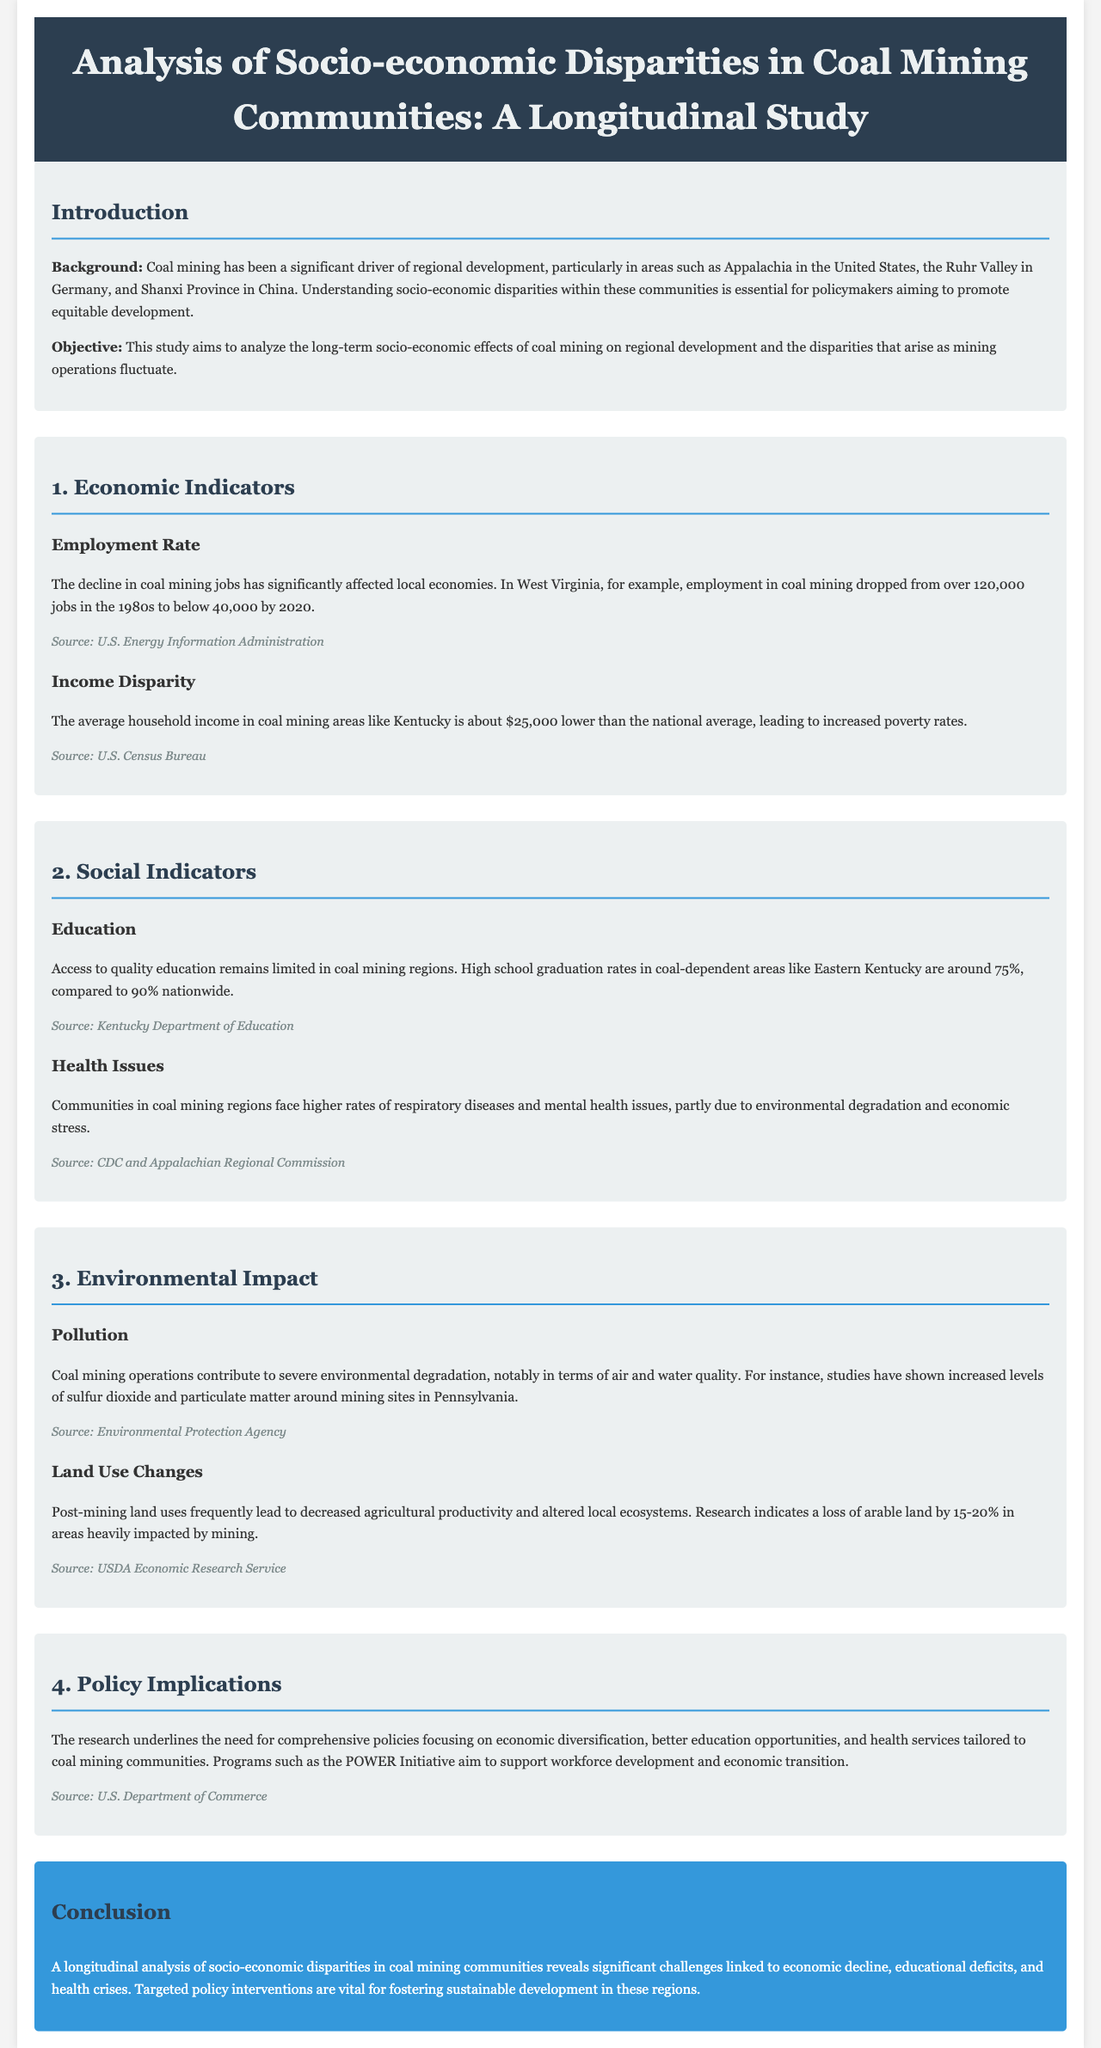what was the employment rate in West Virginia in the 1980s? The employment in coal mining in West Virginia was over 120,000 jobs in the 1980s.
Answer: over 120,000 jobs how much lower is the average household income in coal mining areas like Kentucky compared to the national average? The average household income in coal mining areas like Kentucky is about $25,000 lower than the national average.
Answer: $25,000 lower what is the high school graduation rate in Eastern Kentucky? The high school graduation rate in coal-dependent areas like Eastern Kentucky is around 75%.
Answer: around 75% what percentage of arable land has been lost in areas heavily impacted by mining? Research indicates a loss of arable land by 15-20% in areas heavily impacted by mining.
Answer: 15-20% which initiative aims to support workforce development and economic transition? Programs such as the POWER Initiative aim to support workforce development and economic transition.
Answer: POWER Initiative what are some health issues faced by coal mining communities? Communities in coal mining regions face higher rates of respiratory diseases and mental health issues.
Answer: respiratory diseases and mental health issues what is a significant background factor influencing coal mining communities? Coal mining has been a significant driver of regional development.
Answer: regional development why is understanding socio-economic disparities in coal mining communities essential? Understanding socio-economic disparities is essential for policymakers aiming to promote equitable development.
Answer: promote equitable development what is the main conclusion of the study? Targeted policy interventions are vital for fostering sustainable development in these regions.
Answer: vital for fostering sustainable development 